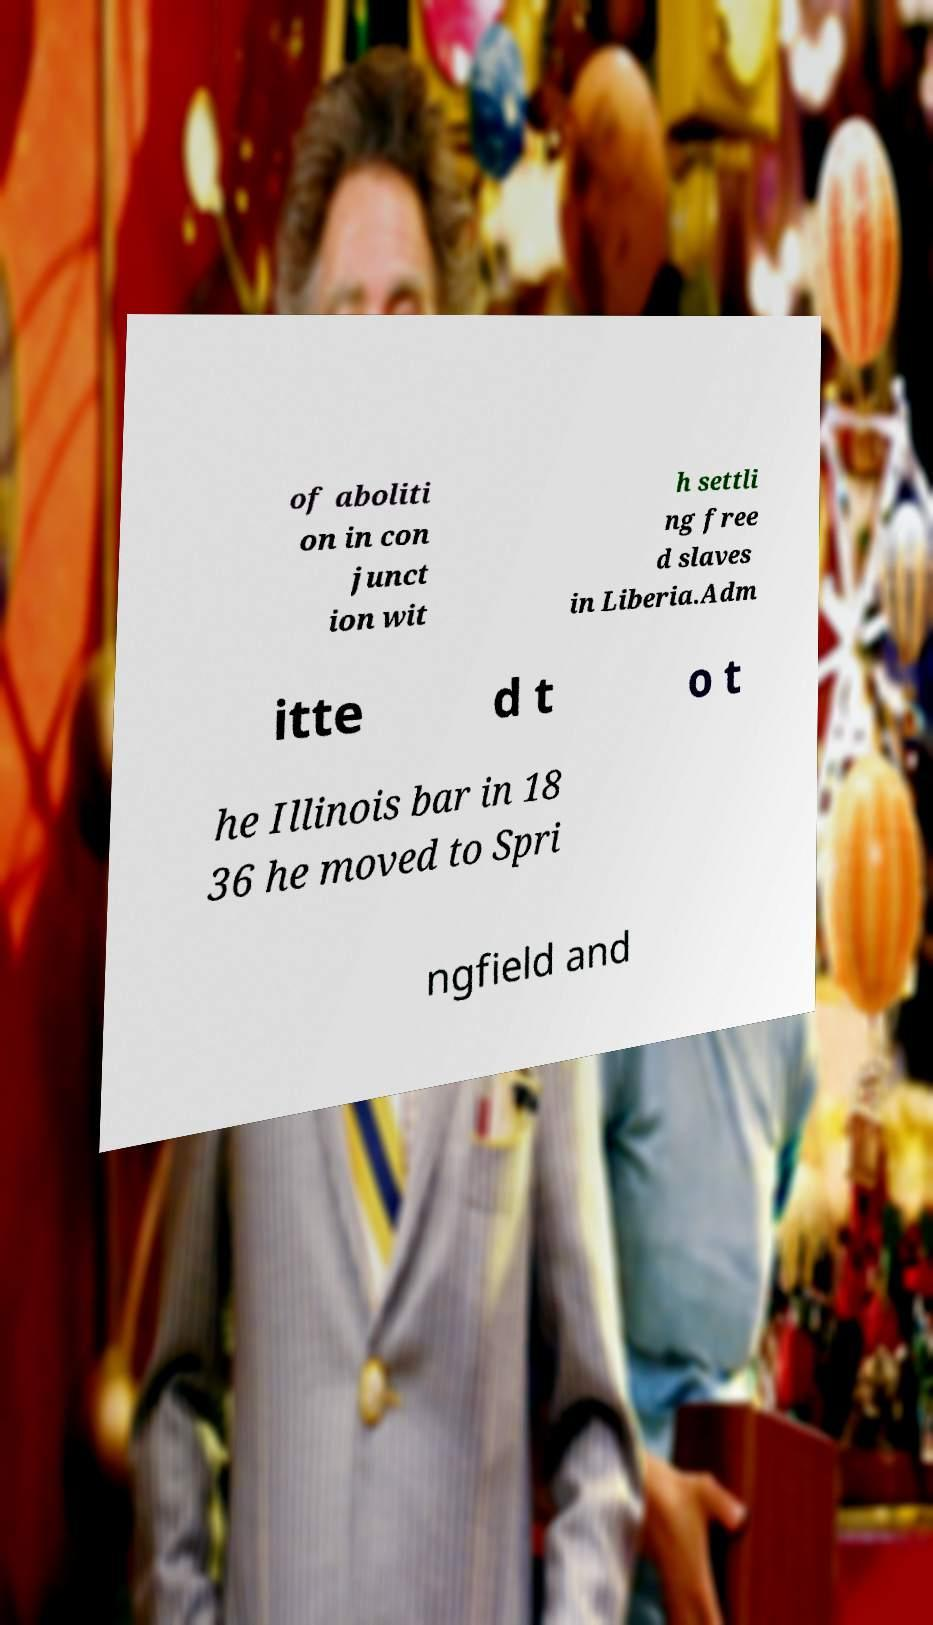There's text embedded in this image that I need extracted. Can you transcribe it verbatim? of aboliti on in con junct ion wit h settli ng free d slaves in Liberia.Adm itte d t o t he Illinois bar in 18 36 he moved to Spri ngfield and 